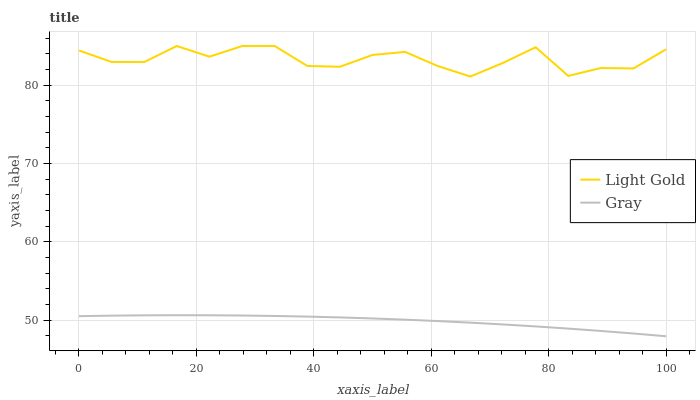Does Light Gold have the minimum area under the curve?
Answer yes or no. No. Is Light Gold the smoothest?
Answer yes or no. No. Does Light Gold have the lowest value?
Answer yes or no. No. Is Gray less than Light Gold?
Answer yes or no. Yes. Is Light Gold greater than Gray?
Answer yes or no. Yes. Does Gray intersect Light Gold?
Answer yes or no. No. 